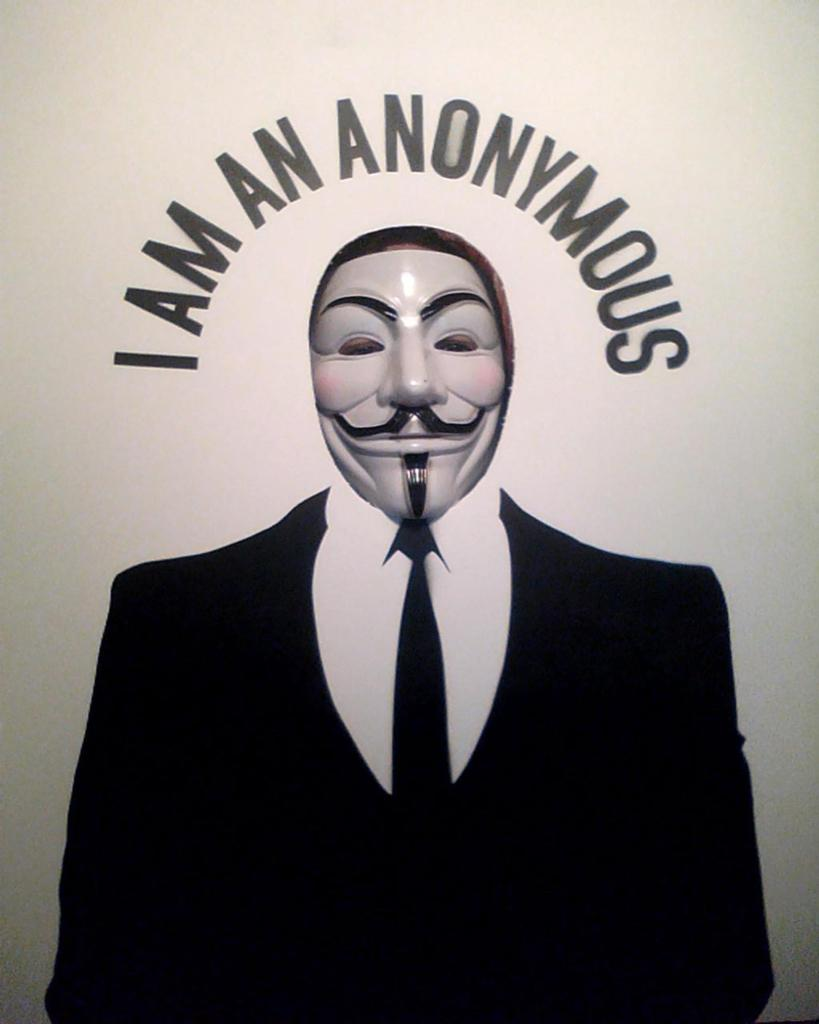What type of clothing items can be seen in the image? There is a suit, a shirt, and a tie in the image. Is there any protective gear present in the image? Yes, there is a mask in the image. Can you describe the mask in the image? The mask has writing on it. What type of car is parked next to the suit in the image? There is no car present in the image; it only features clothing items and a mask. Can you tell me the expert's opinion on the suit in the image? There is no expert present in the image, and the image does not convey any opinions or evaluations of the suit. 